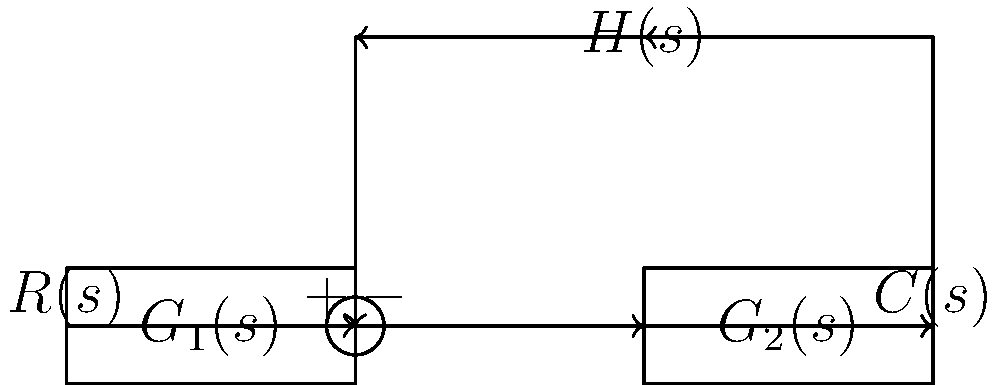In the given block diagram of a feedback control system, what is the transfer function $\frac{C(s)}{R(s)}$ in terms of $G_1(s)$, $G_2(s)$, and $H(s)$? To determine the transfer function $\frac{C(s)}{R(s)}$, we'll follow these steps:

1) First, identify the forward path gain:
   Forward path gain = $G_1(s)G_2(s)$

2) Next, identify the feedback path gain:
   Feedback path gain = $H(s)$

3) The general form of a closed-loop transfer function with negative feedback is:
   $$\frac{C(s)}{R(s)} = \frac{\text{Forward path gain}}{1 + \text{Forward path gain} \times \text{Feedback path gain}}$$

4) Substituting the gains we identified:
   $$\frac{C(s)}{R(s)} = \frac{G_1(s)G_2(s)}{1 + G_1(s)G_2(s)H(s)}$$

5) This expression represents the closed-loop transfer function of the system, relating the output $C(s)$ to the input $R(s)$.
Answer: $$\frac{C(s)}{R(s)} = \frac{G_1(s)G_2(s)}{1 + G_1(s)G_2(s)H(s)}$$ 